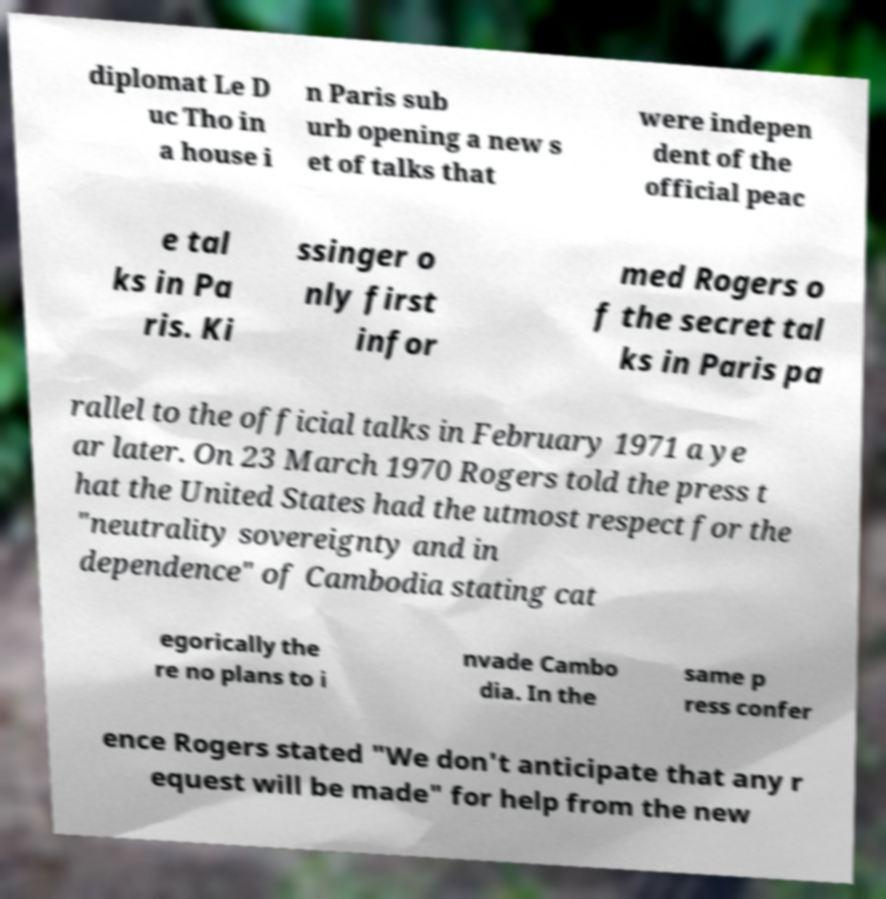Please read and relay the text visible in this image. What does it say? diplomat Le D uc Tho in a house i n Paris sub urb opening a new s et of talks that were indepen dent of the official peac e tal ks in Pa ris. Ki ssinger o nly first infor med Rogers o f the secret tal ks in Paris pa rallel to the official talks in February 1971 a ye ar later. On 23 March 1970 Rogers told the press t hat the United States had the utmost respect for the "neutrality sovereignty and in dependence" of Cambodia stating cat egorically the re no plans to i nvade Cambo dia. In the same p ress confer ence Rogers stated "We don't anticipate that any r equest will be made" for help from the new 